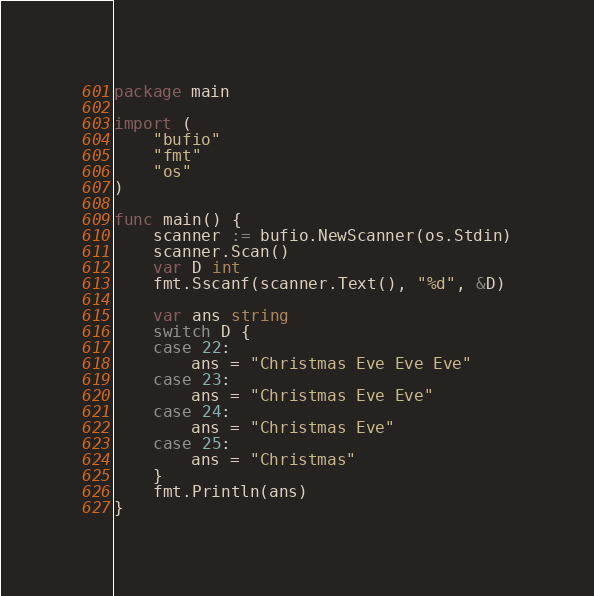Convert code to text. <code><loc_0><loc_0><loc_500><loc_500><_Go_>package main

import (
	"bufio"
	"fmt"
	"os"
)

func main() {
	scanner := bufio.NewScanner(os.Stdin)
	scanner.Scan()
	var D int
	fmt.Sscanf(scanner.Text(), "%d", &D)

	var ans string
	switch D {
	case 22:
		ans = "Christmas Eve Eve Eve"
	case 23:
		ans = "Christmas Eve Eve"
	case 24:
		ans = "Christmas Eve"
	case 25:
		ans = "Christmas"
	}
	fmt.Println(ans)
}
</code> 